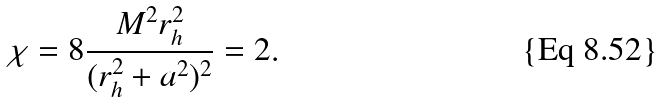Convert formula to latex. <formula><loc_0><loc_0><loc_500><loc_500>\chi = 8 \frac { M ^ { 2 } r _ { h } ^ { 2 } } { ( r _ { h } ^ { 2 } + a ^ { 2 } ) ^ { 2 } } = 2 .</formula> 